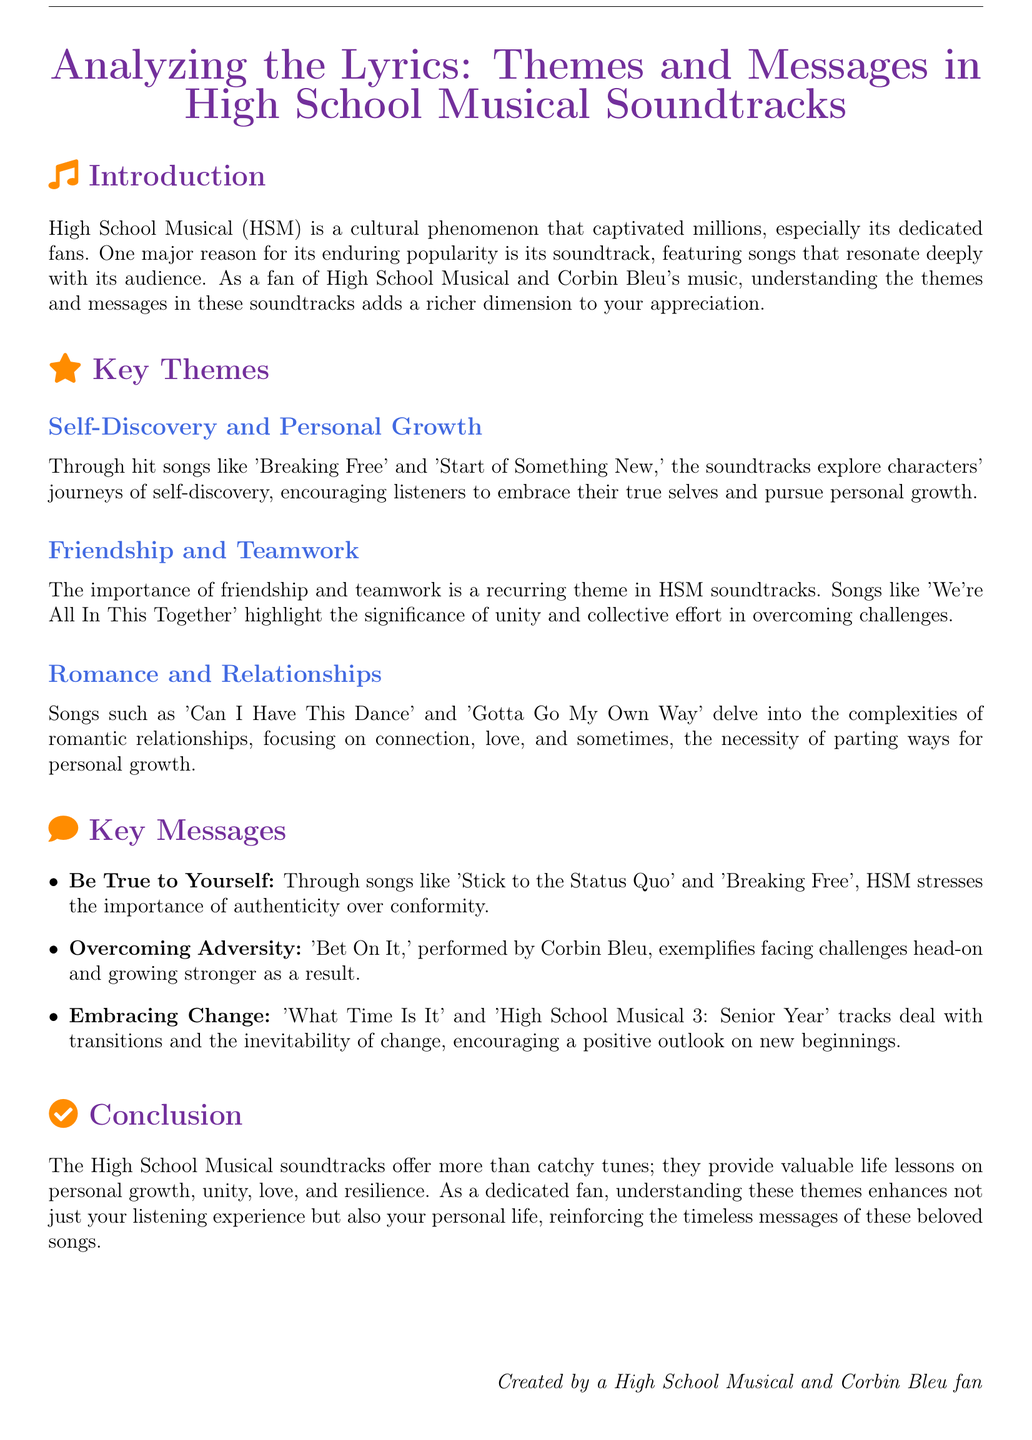What are the key themes discussed in the document? The key themes include Self-Discovery and Personal Growth, Friendship and Teamwork, and Romance and Relationships.
Answer: Self-Discovery and Personal Growth, Friendship and Teamwork, Romance and Relationships Who performed the song 'Bet On It'? The song 'Bet On It' is performed by Corbin Bleu.
Answer: Corbin Bleu What does the song 'We're All In This Together' emphasize? The song emphasizes the significance of unity and collective effort in overcoming challenges.
Answer: Unity and collective effort What is one key message from the High School Musical soundtracks? One key message is to be true to yourself, highlighted in songs like 'Stick to the Status Quo' and 'Breaking Free'.
Answer: Be True to Yourself Which song discusses the necessity of parting ways? The song 'Gotta Go My Own Way' discusses the necessity of parting ways for personal growth.
Answer: Gotta Go My Own Way 